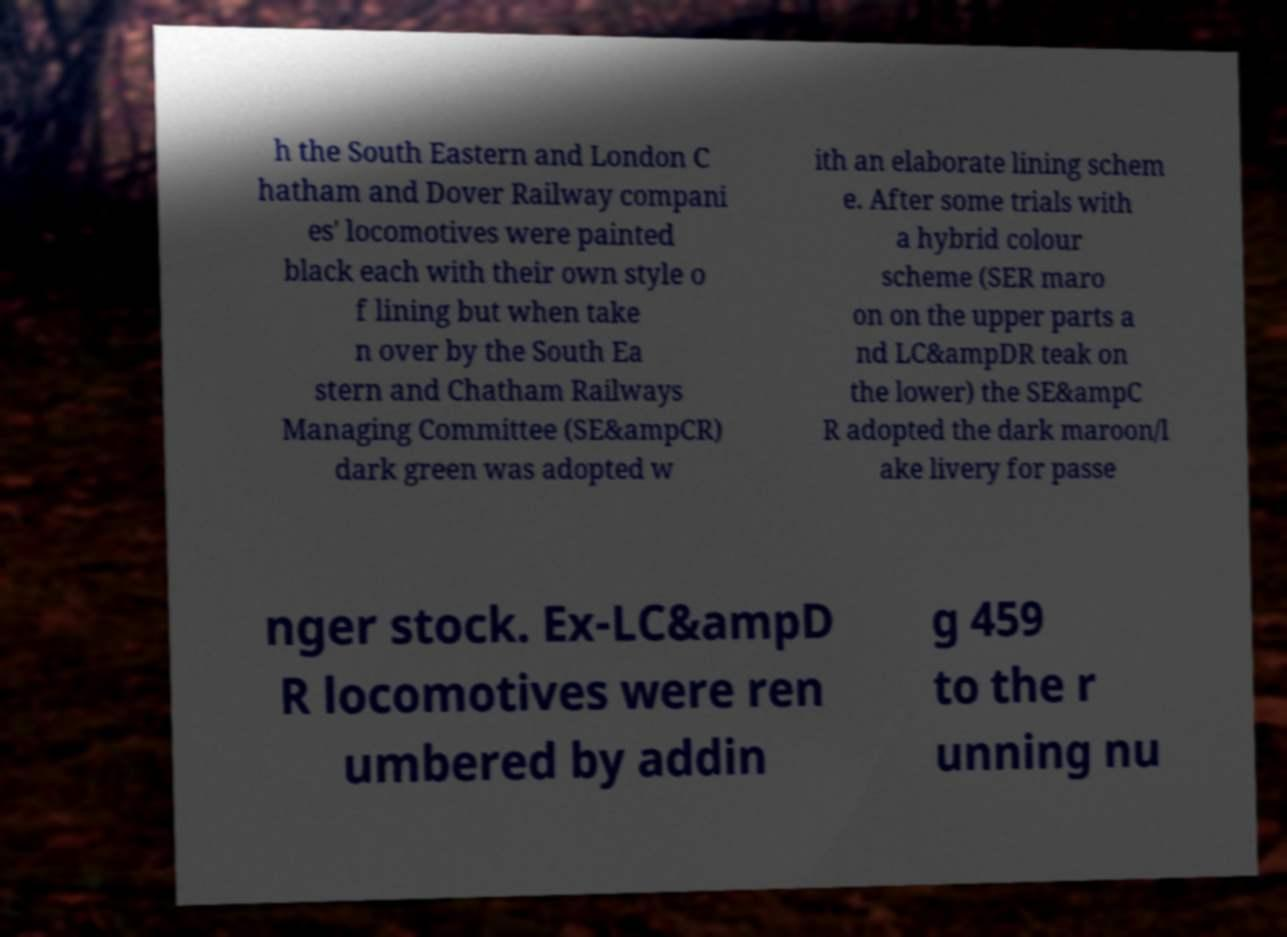For documentation purposes, I need the text within this image transcribed. Could you provide that? h the South Eastern and London C hatham and Dover Railway compani es' locomotives were painted black each with their own style o f lining but when take n over by the South Ea stern and Chatham Railways Managing Committee (SE&ampCR) dark green was adopted w ith an elaborate lining schem e. After some trials with a hybrid colour scheme (SER maro on on the upper parts a nd LC&ampDR teak on the lower) the SE&ampC R adopted the dark maroon/l ake livery for passe nger stock. Ex-LC&ampD R locomotives were ren umbered by addin g 459 to the r unning nu 